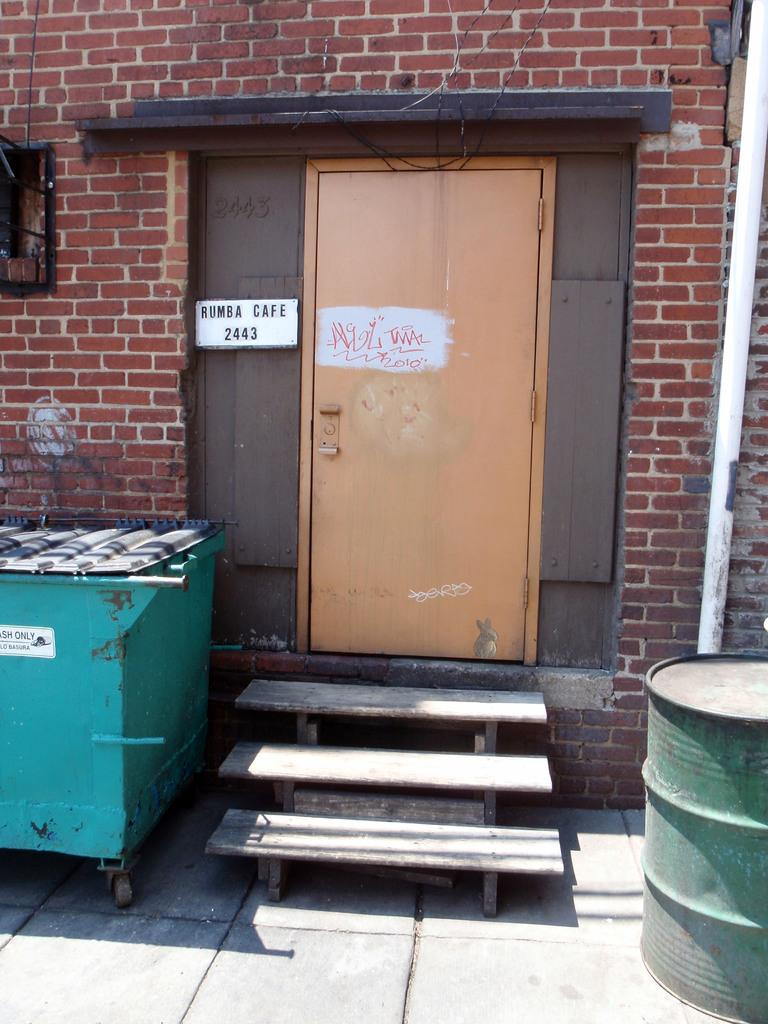What type of structure can be seen in the image? There is a wall with a door in the image. Are there any architectural features present in the image? Yes, there are stairs on the left side of the image. What object is located beside the stairs? There is an object beside the stairs on the left side of the image, but the specific object is not mentioned in the facts. What musical instrument is on the floor on the right side of the image? There is a drum on the floor on the right side of the image. How many cherries are on the drum in the image? There are no cherries present in the image, and the drum is not mentioned as having cherries on it. Can you see any mice running around the stairs in the image? There is no mention of mice in the image, so it cannot be determined if any are present. 